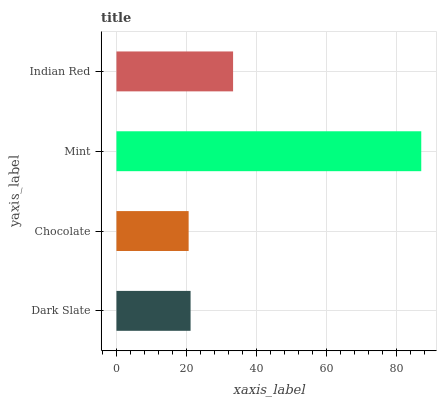Is Chocolate the minimum?
Answer yes or no. Yes. Is Mint the maximum?
Answer yes or no. Yes. Is Mint the minimum?
Answer yes or no. No. Is Chocolate the maximum?
Answer yes or no. No. Is Mint greater than Chocolate?
Answer yes or no. Yes. Is Chocolate less than Mint?
Answer yes or no. Yes. Is Chocolate greater than Mint?
Answer yes or no. No. Is Mint less than Chocolate?
Answer yes or no. No. Is Indian Red the high median?
Answer yes or no. Yes. Is Dark Slate the low median?
Answer yes or no. Yes. Is Dark Slate the high median?
Answer yes or no. No. Is Mint the low median?
Answer yes or no. No. 